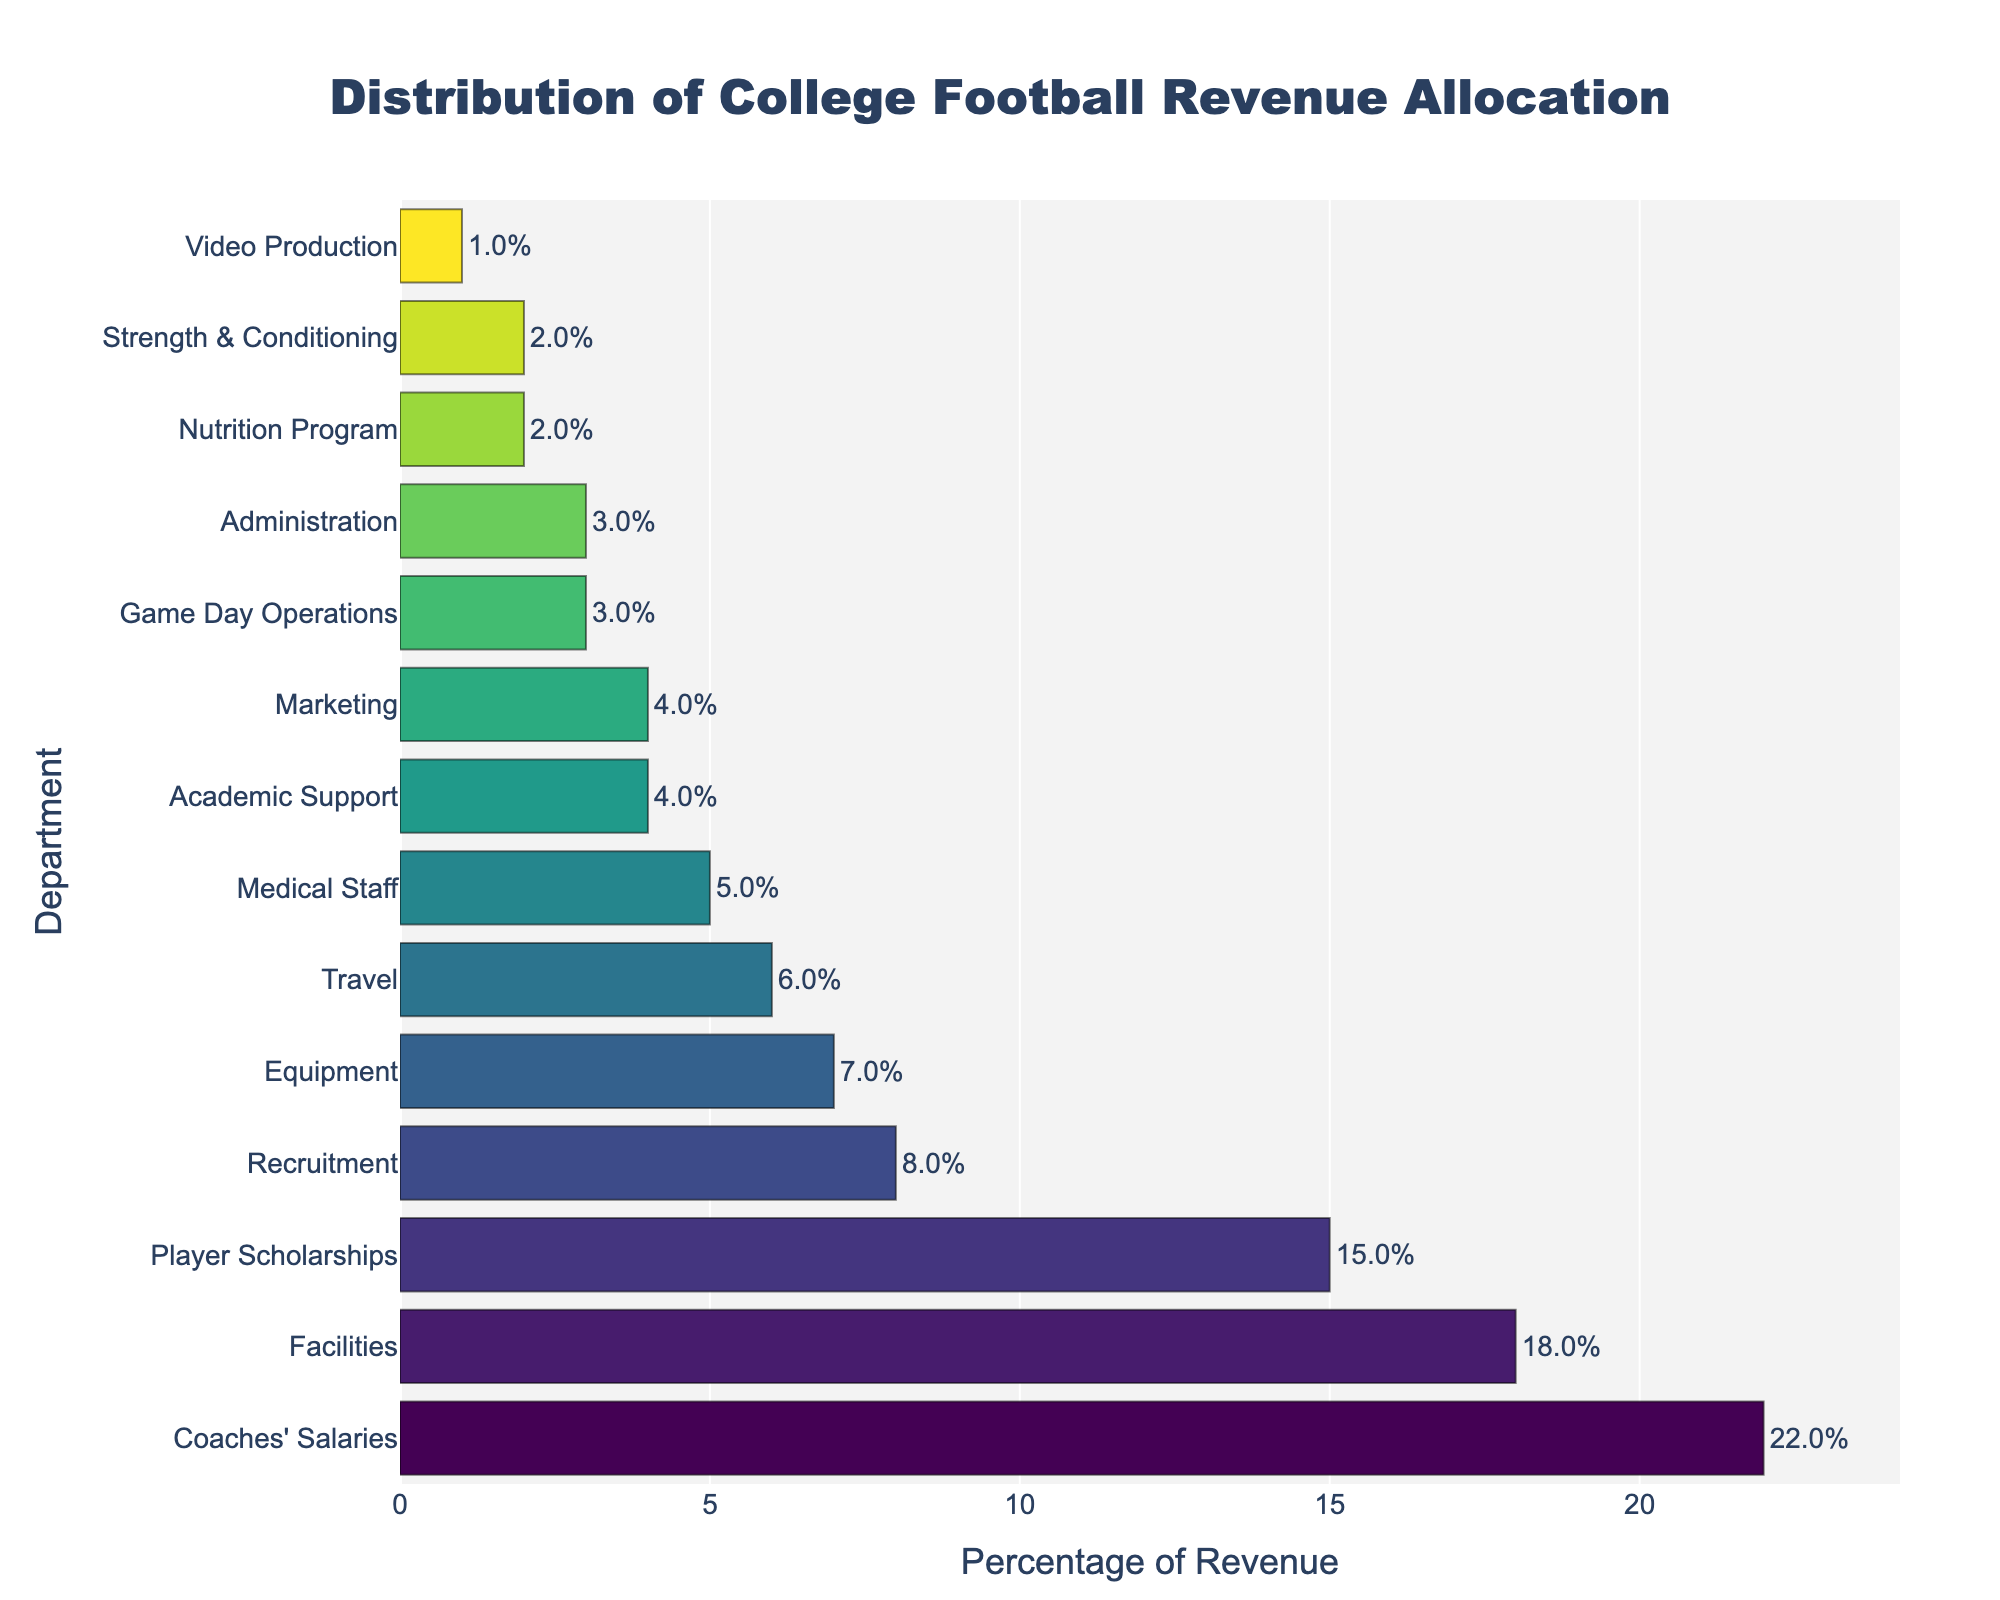Which department receives the highest percentage of revenue? The highest bar corresponds to Coaches' Salaries with a percentage of 22%.
Answer: Coaches' Salaries How does the percentage for Facilities compare to Travel? Facilities are allocated 18%, while Travel is allocated 6%. Therefore, Facilities receive a higher percentage than Travel.
Answer: Facilities receive a higher percentage What is the total percentage of revenue allocated to Recruitment, Medical Staff, and Academic Support combined? Add the percentages for Recruitment (8%), Medical Staff (5%), and Academic Support (4%): 8 + 5 + 4 = 17%.
Answer: 17% Which has a greater percentage allocation, Marketing or Equipment? Marketing has a percentage of 4%, and Equipment has a percentage of 7%. Therefore, Equipment has a greater allocation than Marketing.
Answer: Equipment What is the difference in percentage allocation between Coaches' Salaries and the Nutrition Program? Coaches' Salaries have 22%, and the Nutrition Program has 2%. The difference is 22% - 2% = 20%.
Answer: 20% Is the visual height of bar for Facilities longer than that of Player Scholarships? Yes, the bar for Facilities (18%) is slightly longer than the bar for Player Scholarships (15%). Both bars are visually distinct in length.
Answer: Yes If we sum up the percentages allocated to Facilities, Equipment, and Strength & Conditioning, what portion of revenue do they represent? Add the percentages for Facilities (18%), Equipment (7%), and Strength & Conditioning (2%): 18 + 7 + 2 = 27%.
Answer: 27% How much more revenue, percentage-wise, is allocated to Coaches' Salaries compared to Academic Support? Coaches' Salaries have 22% and Academic Support has 4%. The difference is 22% - 4% = 18%.
Answer: 18% Which department has the least percentage of revenue allocation and what is that percentage? The shortest bar corresponds to Video Production, which has 1% of the revenue allocation.
Answer: Video Production, 1% What is the average percentage allocation for the Nutrition Program and the Strength & Conditioning departments? Add the percentages for the Nutrition Program (2%) and Strength & Conditioning (2%), then divide by 2: (2 + 2)/2 = 2%.
Answer: 2% 